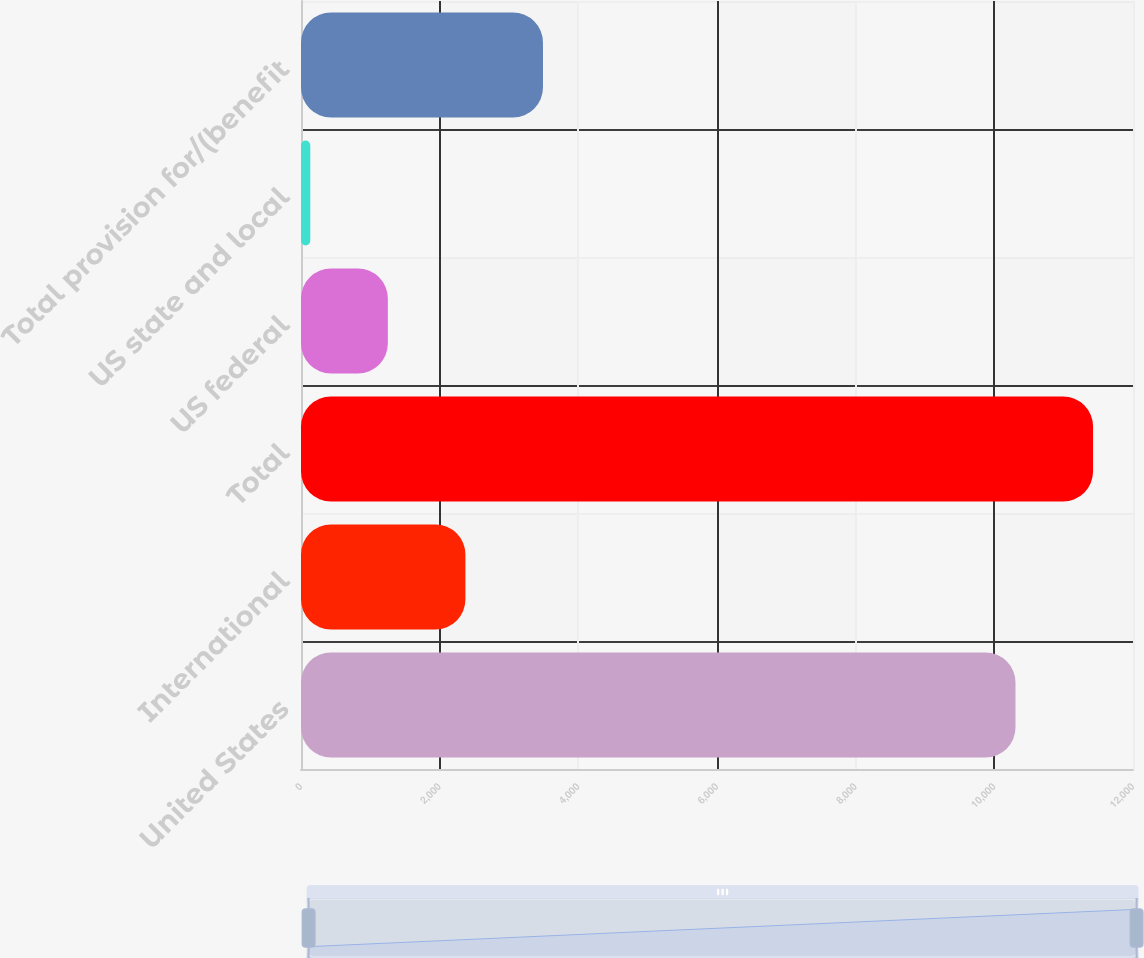<chart> <loc_0><loc_0><loc_500><loc_500><bar_chart><fcel>United States<fcel>International<fcel>Total<fcel>US federal<fcel>US state and local<fcel>Total provision for/(benefit<nl><fcel>10305<fcel>2371.4<fcel>11423.7<fcel>1252.7<fcel>134<fcel>3490.1<nl></chart> 